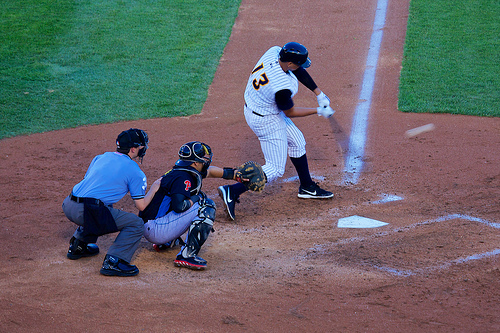Is the ball to the right or to the left of the person that is wearing a glove? The ball is positioned to the right of the catcher, who is wearing the glove. 